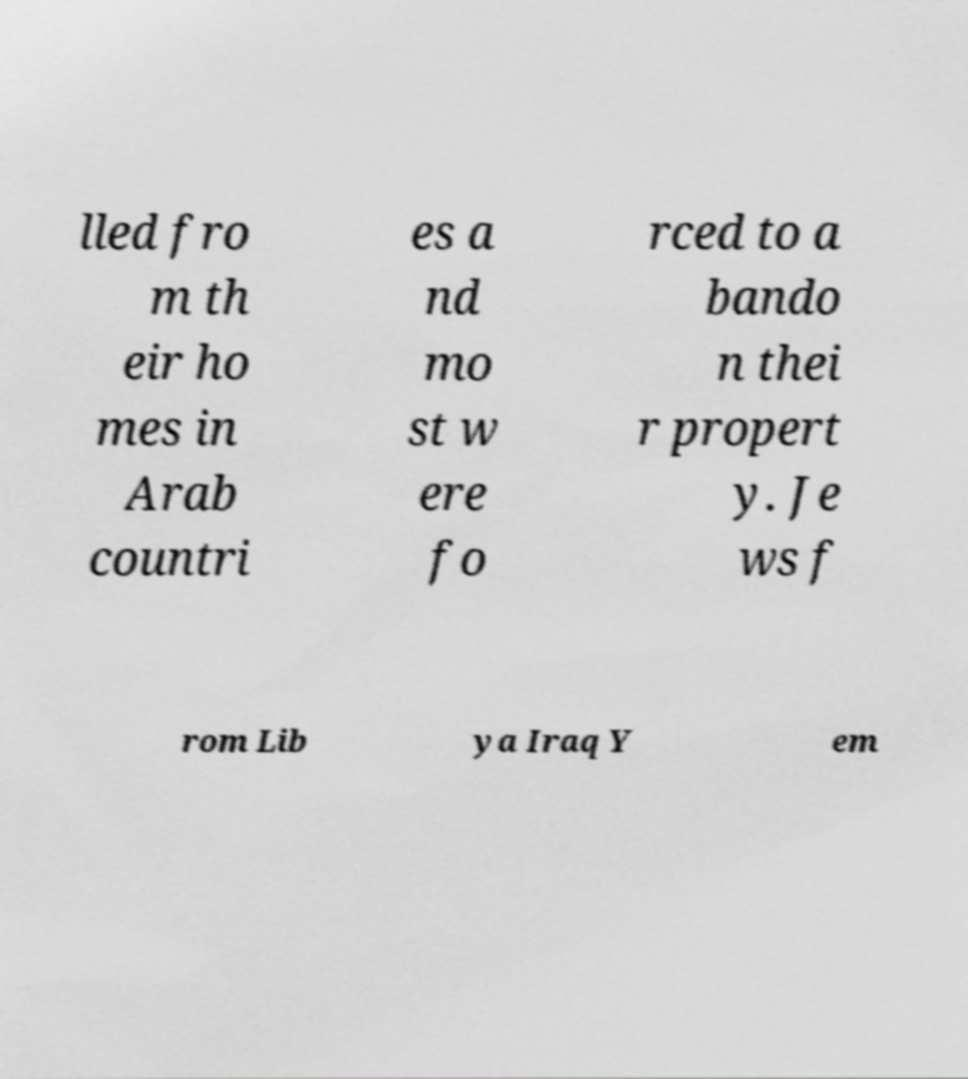There's text embedded in this image that I need extracted. Can you transcribe it verbatim? lled fro m th eir ho mes in Arab countri es a nd mo st w ere fo rced to a bando n thei r propert y. Je ws f rom Lib ya Iraq Y em 